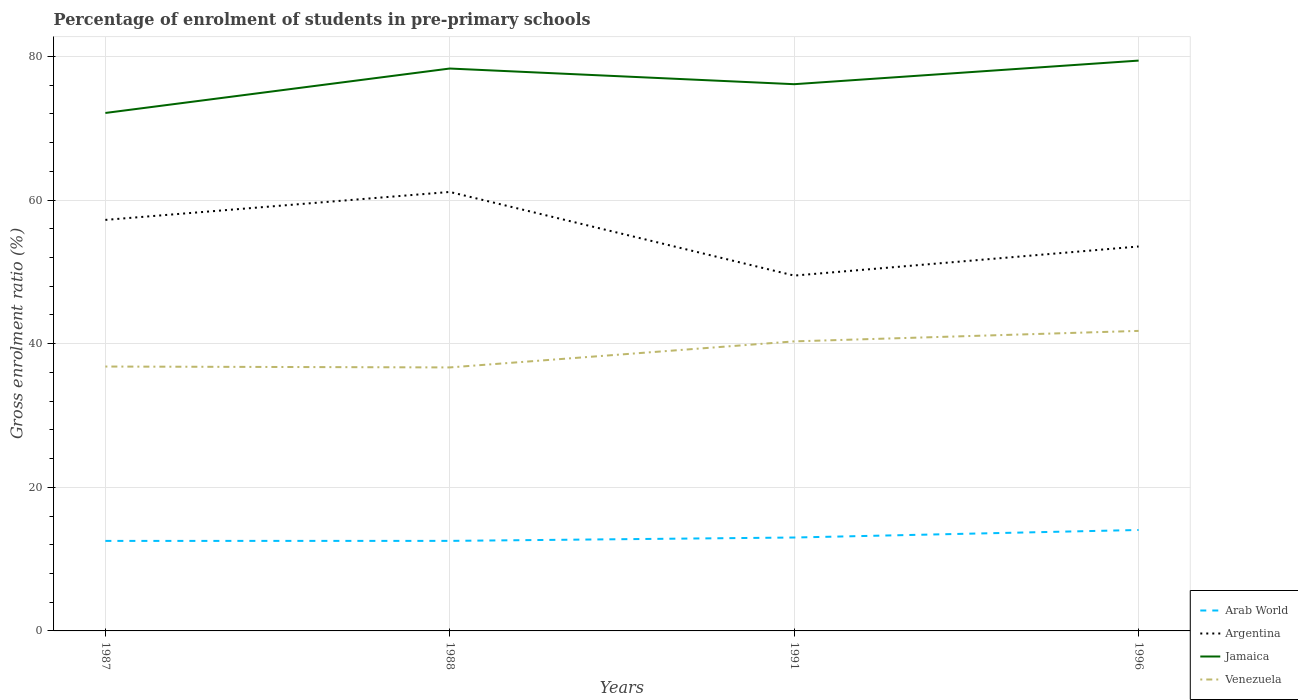Across all years, what is the maximum percentage of students enrolled in pre-primary schools in Venezuela?
Your answer should be compact. 36.69. In which year was the percentage of students enrolled in pre-primary schools in Venezuela maximum?
Offer a very short reply. 1988. What is the total percentage of students enrolled in pre-primary schools in Jamaica in the graph?
Give a very brief answer. 2.18. What is the difference between the highest and the second highest percentage of students enrolled in pre-primary schools in Jamaica?
Your answer should be compact. 7.29. What is the difference between the highest and the lowest percentage of students enrolled in pre-primary schools in Arab World?
Offer a very short reply. 1. How many lines are there?
Provide a succinct answer. 4. Does the graph contain any zero values?
Provide a succinct answer. No. Does the graph contain grids?
Provide a succinct answer. Yes. How are the legend labels stacked?
Give a very brief answer. Vertical. What is the title of the graph?
Ensure brevity in your answer.  Percentage of enrolment of students in pre-primary schools. What is the label or title of the Y-axis?
Offer a very short reply. Gross enrolment ratio (%). What is the Gross enrolment ratio (%) in Arab World in 1987?
Your answer should be compact. 12.53. What is the Gross enrolment ratio (%) in Argentina in 1987?
Make the answer very short. 57.24. What is the Gross enrolment ratio (%) of Jamaica in 1987?
Ensure brevity in your answer.  72.13. What is the Gross enrolment ratio (%) in Venezuela in 1987?
Offer a terse response. 36.82. What is the Gross enrolment ratio (%) of Arab World in 1988?
Keep it short and to the point. 12.54. What is the Gross enrolment ratio (%) in Argentina in 1988?
Keep it short and to the point. 61.13. What is the Gross enrolment ratio (%) in Jamaica in 1988?
Your response must be concise. 78.32. What is the Gross enrolment ratio (%) in Venezuela in 1988?
Your answer should be compact. 36.69. What is the Gross enrolment ratio (%) of Arab World in 1991?
Provide a short and direct response. 13.01. What is the Gross enrolment ratio (%) in Argentina in 1991?
Your answer should be compact. 49.48. What is the Gross enrolment ratio (%) of Jamaica in 1991?
Make the answer very short. 76.13. What is the Gross enrolment ratio (%) of Venezuela in 1991?
Your answer should be compact. 40.32. What is the Gross enrolment ratio (%) of Arab World in 1996?
Make the answer very short. 14.06. What is the Gross enrolment ratio (%) of Argentina in 1996?
Offer a very short reply. 53.53. What is the Gross enrolment ratio (%) in Jamaica in 1996?
Ensure brevity in your answer.  79.42. What is the Gross enrolment ratio (%) of Venezuela in 1996?
Your answer should be very brief. 41.78. Across all years, what is the maximum Gross enrolment ratio (%) of Arab World?
Keep it short and to the point. 14.06. Across all years, what is the maximum Gross enrolment ratio (%) in Argentina?
Keep it short and to the point. 61.13. Across all years, what is the maximum Gross enrolment ratio (%) of Jamaica?
Make the answer very short. 79.42. Across all years, what is the maximum Gross enrolment ratio (%) in Venezuela?
Make the answer very short. 41.78. Across all years, what is the minimum Gross enrolment ratio (%) of Arab World?
Offer a terse response. 12.53. Across all years, what is the minimum Gross enrolment ratio (%) of Argentina?
Your answer should be very brief. 49.48. Across all years, what is the minimum Gross enrolment ratio (%) of Jamaica?
Your response must be concise. 72.13. Across all years, what is the minimum Gross enrolment ratio (%) of Venezuela?
Offer a terse response. 36.69. What is the total Gross enrolment ratio (%) in Arab World in the graph?
Ensure brevity in your answer.  52.14. What is the total Gross enrolment ratio (%) in Argentina in the graph?
Your response must be concise. 221.38. What is the total Gross enrolment ratio (%) in Jamaica in the graph?
Make the answer very short. 305.99. What is the total Gross enrolment ratio (%) in Venezuela in the graph?
Your response must be concise. 155.61. What is the difference between the Gross enrolment ratio (%) of Arab World in 1987 and that in 1988?
Give a very brief answer. -0. What is the difference between the Gross enrolment ratio (%) in Argentina in 1987 and that in 1988?
Make the answer very short. -3.89. What is the difference between the Gross enrolment ratio (%) in Jamaica in 1987 and that in 1988?
Ensure brevity in your answer.  -6.19. What is the difference between the Gross enrolment ratio (%) of Venezuela in 1987 and that in 1988?
Make the answer very short. 0.12. What is the difference between the Gross enrolment ratio (%) of Arab World in 1987 and that in 1991?
Ensure brevity in your answer.  -0.47. What is the difference between the Gross enrolment ratio (%) of Argentina in 1987 and that in 1991?
Offer a very short reply. 7.76. What is the difference between the Gross enrolment ratio (%) of Jamaica in 1987 and that in 1991?
Give a very brief answer. -4.01. What is the difference between the Gross enrolment ratio (%) in Venezuela in 1987 and that in 1991?
Keep it short and to the point. -3.5. What is the difference between the Gross enrolment ratio (%) of Arab World in 1987 and that in 1996?
Keep it short and to the point. -1.52. What is the difference between the Gross enrolment ratio (%) in Argentina in 1987 and that in 1996?
Your answer should be compact. 3.7. What is the difference between the Gross enrolment ratio (%) in Jamaica in 1987 and that in 1996?
Keep it short and to the point. -7.29. What is the difference between the Gross enrolment ratio (%) of Venezuela in 1987 and that in 1996?
Offer a terse response. -4.96. What is the difference between the Gross enrolment ratio (%) in Arab World in 1988 and that in 1991?
Provide a short and direct response. -0.47. What is the difference between the Gross enrolment ratio (%) of Argentina in 1988 and that in 1991?
Ensure brevity in your answer.  11.65. What is the difference between the Gross enrolment ratio (%) of Jamaica in 1988 and that in 1991?
Give a very brief answer. 2.18. What is the difference between the Gross enrolment ratio (%) of Venezuela in 1988 and that in 1991?
Keep it short and to the point. -3.63. What is the difference between the Gross enrolment ratio (%) of Arab World in 1988 and that in 1996?
Provide a succinct answer. -1.52. What is the difference between the Gross enrolment ratio (%) in Argentina in 1988 and that in 1996?
Provide a succinct answer. 7.6. What is the difference between the Gross enrolment ratio (%) of Jamaica in 1988 and that in 1996?
Your answer should be very brief. -1.1. What is the difference between the Gross enrolment ratio (%) of Venezuela in 1988 and that in 1996?
Give a very brief answer. -5.09. What is the difference between the Gross enrolment ratio (%) in Arab World in 1991 and that in 1996?
Offer a terse response. -1.05. What is the difference between the Gross enrolment ratio (%) of Argentina in 1991 and that in 1996?
Give a very brief answer. -4.05. What is the difference between the Gross enrolment ratio (%) in Jamaica in 1991 and that in 1996?
Offer a very short reply. -3.29. What is the difference between the Gross enrolment ratio (%) of Venezuela in 1991 and that in 1996?
Ensure brevity in your answer.  -1.46. What is the difference between the Gross enrolment ratio (%) of Arab World in 1987 and the Gross enrolment ratio (%) of Argentina in 1988?
Keep it short and to the point. -48.59. What is the difference between the Gross enrolment ratio (%) in Arab World in 1987 and the Gross enrolment ratio (%) in Jamaica in 1988?
Your answer should be very brief. -65.78. What is the difference between the Gross enrolment ratio (%) in Arab World in 1987 and the Gross enrolment ratio (%) in Venezuela in 1988?
Your response must be concise. -24.16. What is the difference between the Gross enrolment ratio (%) in Argentina in 1987 and the Gross enrolment ratio (%) in Jamaica in 1988?
Ensure brevity in your answer.  -21.08. What is the difference between the Gross enrolment ratio (%) in Argentina in 1987 and the Gross enrolment ratio (%) in Venezuela in 1988?
Your answer should be very brief. 20.54. What is the difference between the Gross enrolment ratio (%) in Jamaica in 1987 and the Gross enrolment ratio (%) in Venezuela in 1988?
Offer a terse response. 35.43. What is the difference between the Gross enrolment ratio (%) of Arab World in 1987 and the Gross enrolment ratio (%) of Argentina in 1991?
Your answer should be compact. -36.95. What is the difference between the Gross enrolment ratio (%) in Arab World in 1987 and the Gross enrolment ratio (%) in Jamaica in 1991?
Give a very brief answer. -63.6. What is the difference between the Gross enrolment ratio (%) in Arab World in 1987 and the Gross enrolment ratio (%) in Venezuela in 1991?
Your response must be concise. -27.79. What is the difference between the Gross enrolment ratio (%) in Argentina in 1987 and the Gross enrolment ratio (%) in Jamaica in 1991?
Offer a terse response. -18.9. What is the difference between the Gross enrolment ratio (%) of Argentina in 1987 and the Gross enrolment ratio (%) of Venezuela in 1991?
Your answer should be compact. 16.92. What is the difference between the Gross enrolment ratio (%) in Jamaica in 1987 and the Gross enrolment ratio (%) in Venezuela in 1991?
Give a very brief answer. 31.81. What is the difference between the Gross enrolment ratio (%) in Arab World in 1987 and the Gross enrolment ratio (%) in Argentina in 1996?
Ensure brevity in your answer.  -41. What is the difference between the Gross enrolment ratio (%) in Arab World in 1987 and the Gross enrolment ratio (%) in Jamaica in 1996?
Your answer should be very brief. -66.89. What is the difference between the Gross enrolment ratio (%) of Arab World in 1987 and the Gross enrolment ratio (%) of Venezuela in 1996?
Ensure brevity in your answer.  -29.25. What is the difference between the Gross enrolment ratio (%) of Argentina in 1987 and the Gross enrolment ratio (%) of Jamaica in 1996?
Ensure brevity in your answer.  -22.18. What is the difference between the Gross enrolment ratio (%) of Argentina in 1987 and the Gross enrolment ratio (%) of Venezuela in 1996?
Provide a succinct answer. 15.46. What is the difference between the Gross enrolment ratio (%) of Jamaica in 1987 and the Gross enrolment ratio (%) of Venezuela in 1996?
Your answer should be very brief. 30.35. What is the difference between the Gross enrolment ratio (%) of Arab World in 1988 and the Gross enrolment ratio (%) of Argentina in 1991?
Offer a terse response. -36.94. What is the difference between the Gross enrolment ratio (%) of Arab World in 1988 and the Gross enrolment ratio (%) of Jamaica in 1991?
Offer a very short reply. -63.59. What is the difference between the Gross enrolment ratio (%) in Arab World in 1988 and the Gross enrolment ratio (%) in Venezuela in 1991?
Your answer should be very brief. -27.78. What is the difference between the Gross enrolment ratio (%) of Argentina in 1988 and the Gross enrolment ratio (%) of Jamaica in 1991?
Ensure brevity in your answer.  -15. What is the difference between the Gross enrolment ratio (%) of Argentina in 1988 and the Gross enrolment ratio (%) of Venezuela in 1991?
Offer a terse response. 20.81. What is the difference between the Gross enrolment ratio (%) in Jamaica in 1988 and the Gross enrolment ratio (%) in Venezuela in 1991?
Provide a succinct answer. 38. What is the difference between the Gross enrolment ratio (%) of Arab World in 1988 and the Gross enrolment ratio (%) of Argentina in 1996?
Give a very brief answer. -40.99. What is the difference between the Gross enrolment ratio (%) in Arab World in 1988 and the Gross enrolment ratio (%) in Jamaica in 1996?
Your answer should be very brief. -66.88. What is the difference between the Gross enrolment ratio (%) of Arab World in 1988 and the Gross enrolment ratio (%) of Venezuela in 1996?
Keep it short and to the point. -29.24. What is the difference between the Gross enrolment ratio (%) in Argentina in 1988 and the Gross enrolment ratio (%) in Jamaica in 1996?
Give a very brief answer. -18.29. What is the difference between the Gross enrolment ratio (%) of Argentina in 1988 and the Gross enrolment ratio (%) of Venezuela in 1996?
Give a very brief answer. 19.35. What is the difference between the Gross enrolment ratio (%) in Jamaica in 1988 and the Gross enrolment ratio (%) in Venezuela in 1996?
Your answer should be very brief. 36.53. What is the difference between the Gross enrolment ratio (%) of Arab World in 1991 and the Gross enrolment ratio (%) of Argentina in 1996?
Provide a short and direct response. -40.53. What is the difference between the Gross enrolment ratio (%) in Arab World in 1991 and the Gross enrolment ratio (%) in Jamaica in 1996?
Give a very brief answer. -66.41. What is the difference between the Gross enrolment ratio (%) of Arab World in 1991 and the Gross enrolment ratio (%) of Venezuela in 1996?
Your answer should be compact. -28.77. What is the difference between the Gross enrolment ratio (%) in Argentina in 1991 and the Gross enrolment ratio (%) in Jamaica in 1996?
Make the answer very short. -29.94. What is the difference between the Gross enrolment ratio (%) of Argentina in 1991 and the Gross enrolment ratio (%) of Venezuela in 1996?
Your response must be concise. 7.7. What is the difference between the Gross enrolment ratio (%) in Jamaica in 1991 and the Gross enrolment ratio (%) in Venezuela in 1996?
Your response must be concise. 34.35. What is the average Gross enrolment ratio (%) of Arab World per year?
Provide a succinct answer. 13.03. What is the average Gross enrolment ratio (%) in Argentina per year?
Make the answer very short. 55.34. What is the average Gross enrolment ratio (%) in Jamaica per year?
Your answer should be compact. 76.5. What is the average Gross enrolment ratio (%) of Venezuela per year?
Provide a short and direct response. 38.9. In the year 1987, what is the difference between the Gross enrolment ratio (%) of Arab World and Gross enrolment ratio (%) of Argentina?
Offer a very short reply. -44.7. In the year 1987, what is the difference between the Gross enrolment ratio (%) of Arab World and Gross enrolment ratio (%) of Jamaica?
Your answer should be very brief. -59.59. In the year 1987, what is the difference between the Gross enrolment ratio (%) in Arab World and Gross enrolment ratio (%) in Venezuela?
Provide a succinct answer. -24.28. In the year 1987, what is the difference between the Gross enrolment ratio (%) of Argentina and Gross enrolment ratio (%) of Jamaica?
Provide a succinct answer. -14.89. In the year 1987, what is the difference between the Gross enrolment ratio (%) in Argentina and Gross enrolment ratio (%) in Venezuela?
Your answer should be compact. 20.42. In the year 1987, what is the difference between the Gross enrolment ratio (%) in Jamaica and Gross enrolment ratio (%) in Venezuela?
Offer a terse response. 35.31. In the year 1988, what is the difference between the Gross enrolment ratio (%) of Arab World and Gross enrolment ratio (%) of Argentina?
Provide a short and direct response. -48.59. In the year 1988, what is the difference between the Gross enrolment ratio (%) in Arab World and Gross enrolment ratio (%) in Jamaica?
Keep it short and to the point. -65.78. In the year 1988, what is the difference between the Gross enrolment ratio (%) of Arab World and Gross enrolment ratio (%) of Venezuela?
Your response must be concise. -24.15. In the year 1988, what is the difference between the Gross enrolment ratio (%) in Argentina and Gross enrolment ratio (%) in Jamaica?
Ensure brevity in your answer.  -17.19. In the year 1988, what is the difference between the Gross enrolment ratio (%) of Argentina and Gross enrolment ratio (%) of Venezuela?
Ensure brevity in your answer.  24.44. In the year 1988, what is the difference between the Gross enrolment ratio (%) in Jamaica and Gross enrolment ratio (%) in Venezuela?
Offer a very short reply. 41.62. In the year 1991, what is the difference between the Gross enrolment ratio (%) of Arab World and Gross enrolment ratio (%) of Argentina?
Provide a succinct answer. -36.47. In the year 1991, what is the difference between the Gross enrolment ratio (%) in Arab World and Gross enrolment ratio (%) in Jamaica?
Offer a terse response. -63.13. In the year 1991, what is the difference between the Gross enrolment ratio (%) of Arab World and Gross enrolment ratio (%) of Venezuela?
Make the answer very short. -27.31. In the year 1991, what is the difference between the Gross enrolment ratio (%) in Argentina and Gross enrolment ratio (%) in Jamaica?
Your answer should be compact. -26.65. In the year 1991, what is the difference between the Gross enrolment ratio (%) of Argentina and Gross enrolment ratio (%) of Venezuela?
Your response must be concise. 9.16. In the year 1991, what is the difference between the Gross enrolment ratio (%) in Jamaica and Gross enrolment ratio (%) in Venezuela?
Offer a terse response. 35.81. In the year 1996, what is the difference between the Gross enrolment ratio (%) of Arab World and Gross enrolment ratio (%) of Argentina?
Your answer should be compact. -39.48. In the year 1996, what is the difference between the Gross enrolment ratio (%) of Arab World and Gross enrolment ratio (%) of Jamaica?
Provide a short and direct response. -65.36. In the year 1996, what is the difference between the Gross enrolment ratio (%) in Arab World and Gross enrolment ratio (%) in Venezuela?
Provide a short and direct response. -27.72. In the year 1996, what is the difference between the Gross enrolment ratio (%) of Argentina and Gross enrolment ratio (%) of Jamaica?
Provide a succinct answer. -25.89. In the year 1996, what is the difference between the Gross enrolment ratio (%) in Argentina and Gross enrolment ratio (%) in Venezuela?
Offer a terse response. 11.75. In the year 1996, what is the difference between the Gross enrolment ratio (%) in Jamaica and Gross enrolment ratio (%) in Venezuela?
Your answer should be compact. 37.64. What is the ratio of the Gross enrolment ratio (%) in Arab World in 1987 to that in 1988?
Provide a short and direct response. 1. What is the ratio of the Gross enrolment ratio (%) of Argentina in 1987 to that in 1988?
Give a very brief answer. 0.94. What is the ratio of the Gross enrolment ratio (%) of Jamaica in 1987 to that in 1988?
Provide a succinct answer. 0.92. What is the ratio of the Gross enrolment ratio (%) in Arab World in 1987 to that in 1991?
Provide a short and direct response. 0.96. What is the ratio of the Gross enrolment ratio (%) of Argentina in 1987 to that in 1991?
Offer a terse response. 1.16. What is the ratio of the Gross enrolment ratio (%) in Jamaica in 1987 to that in 1991?
Your response must be concise. 0.95. What is the ratio of the Gross enrolment ratio (%) in Venezuela in 1987 to that in 1991?
Give a very brief answer. 0.91. What is the ratio of the Gross enrolment ratio (%) in Arab World in 1987 to that in 1996?
Provide a short and direct response. 0.89. What is the ratio of the Gross enrolment ratio (%) of Argentina in 1987 to that in 1996?
Provide a short and direct response. 1.07. What is the ratio of the Gross enrolment ratio (%) of Jamaica in 1987 to that in 1996?
Offer a terse response. 0.91. What is the ratio of the Gross enrolment ratio (%) of Venezuela in 1987 to that in 1996?
Offer a terse response. 0.88. What is the ratio of the Gross enrolment ratio (%) in Arab World in 1988 to that in 1991?
Make the answer very short. 0.96. What is the ratio of the Gross enrolment ratio (%) in Argentina in 1988 to that in 1991?
Give a very brief answer. 1.24. What is the ratio of the Gross enrolment ratio (%) in Jamaica in 1988 to that in 1991?
Provide a short and direct response. 1.03. What is the ratio of the Gross enrolment ratio (%) in Venezuela in 1988 to that in 1991?
Offer a very short reply. 0.91. What is the ratio of the Gross enrolment ratio (%) of Arab World in 1988 to that in 1996?
Provide a short and direct response. 0.89. What is the ratio of the Gross enrolment ratio (%) in Argentina in 1988 to that in 1996?
Your answer should be compact. 1.14. What is the ratio of the Gross enrolment ratio (%) in Jamaica in 1988 to that in 1996?
Give a very brief answer. 0.99. What is the ratio of the Gross enrolment ratio (%) in Venezuela in 1988 to that in 1996?
Your answer should be very brief. 0.88. What is the ratio of the Gross enrolment ratio (%) in Arab World in 1991 to that in 1996?
Give a very brief answer. 0.93. What is the ratio of the Gross enrolment ratio (%) of Argentina in 1991 to that in 1996?
Your answer should be compact. 0.92. What is the ratio of the Gross enrolment ratio (%) of Jamaica in 1991 to that in 1996?
Your response must be concise. 0.96. What is the difference between the highest and the second highest Gross enrolment ratio (%) in Arab World?
Offer a very short reply. 1.05. What is the difference between the highest and the second highest Gross enrolment ratio (%) of Argentina?
Make the answer very short. 3.89. What is the difference between the highest and the second highest Gross enrolment ratio (%) in Jamaica?
Your response must be concise. 1.1. What is the difference between the highest and the second highest Gross enrolment ratio (%) in Venezuela?
Keep it short and to the point. 1.46. What is the difference between the highest and the lowest Gross enrolment ratio (%) of Arab World?
Provide a short and direct response. 1.52. What is the difference between the highest and the lowest Gross enrolment ratio (%) in Argentina?
Provide a succinct answer. 11.65. What is the difference between the highest and the lowest Gross enrolment ratio (%) of Jamaica?
Your answer should be compact. 7.29. What is the difference between the highest and the lowest Gross enrolment ratio (%) in Venezuela?
Offer a terse response. 5.09. 